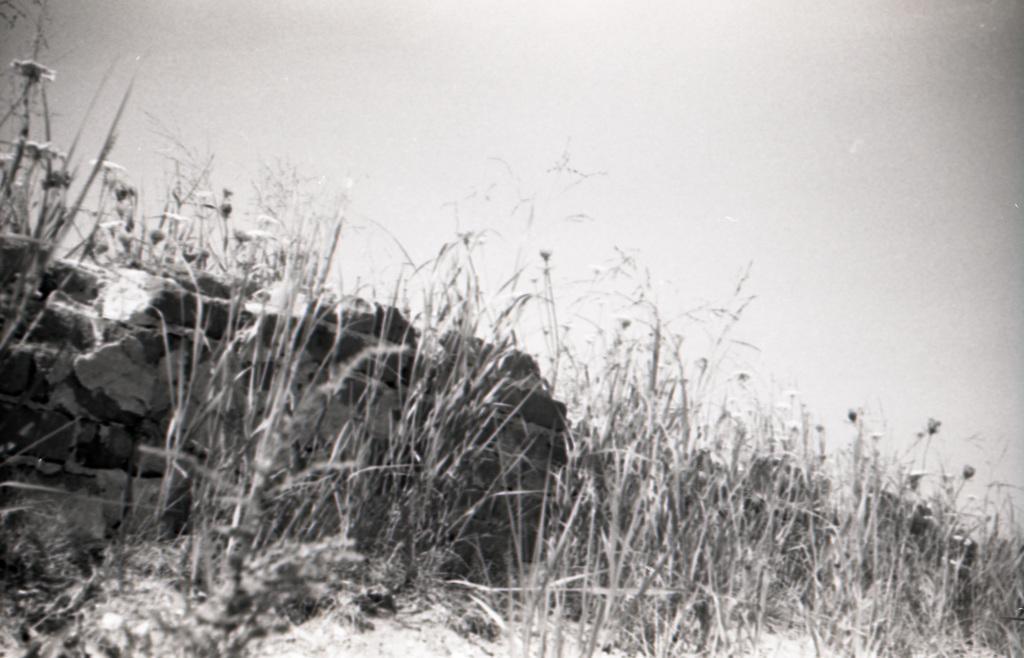How would you summarize this image in a sentence or two? This picture shows plants with flowers and we see a cloudy sky. 